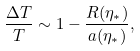Convert formula to latex. <formula><loc_0><loc_0><loc_500><loc_500>\frac { \Delta T } { T } \sim 1 - \frac { R ( \eta _ { * } ) } { a ( \eta _ { * } ) } ,</formula> 